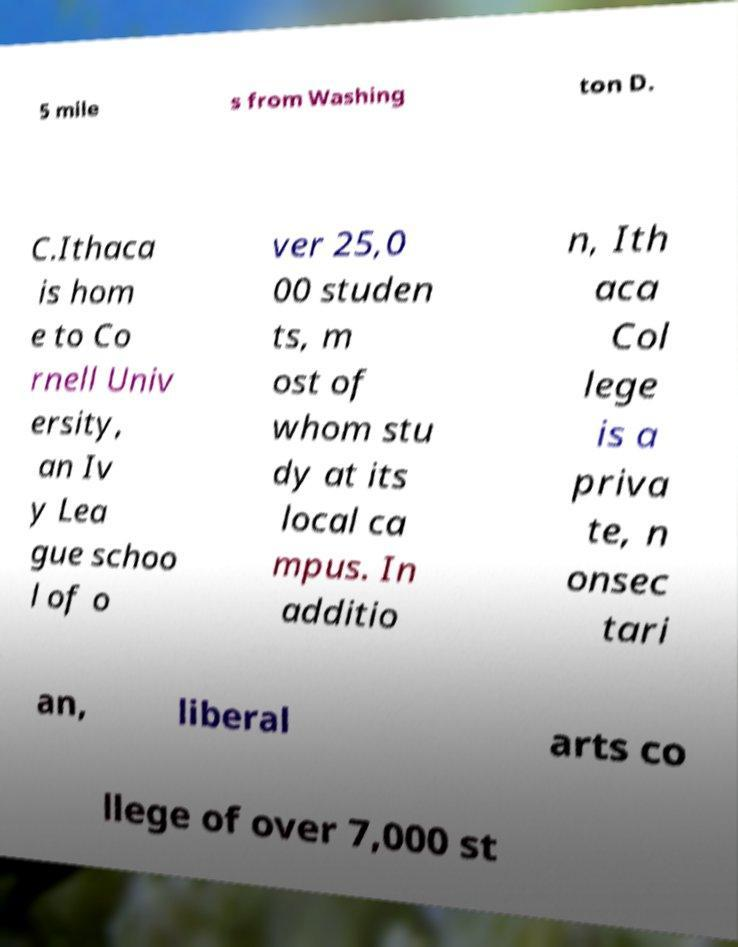What messages or text are displayed in this image? I need them in a readable, typed format. 5 mile s from Washing ton D. C.Ithaca is hom e to Co rnell Univ ersity, an Iv y Lea gue schoo l of o ver 25,0 00 studen ts, m ost of whom stu dy at its local ca mpus. In additio n, Ith aca Col lege is a priva te, n onsec tari an, liberal arts co llege of over 7,000 st 